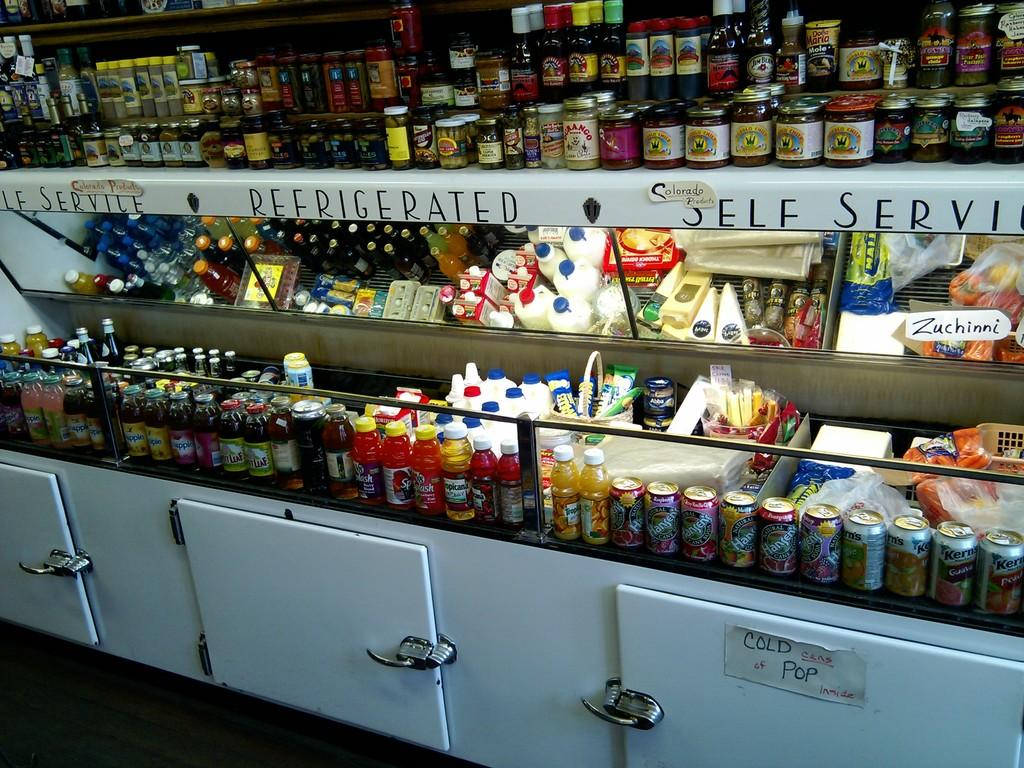<image>
Describe the image concisely. Drinks for sale under a refrigerated section and a self service section. 